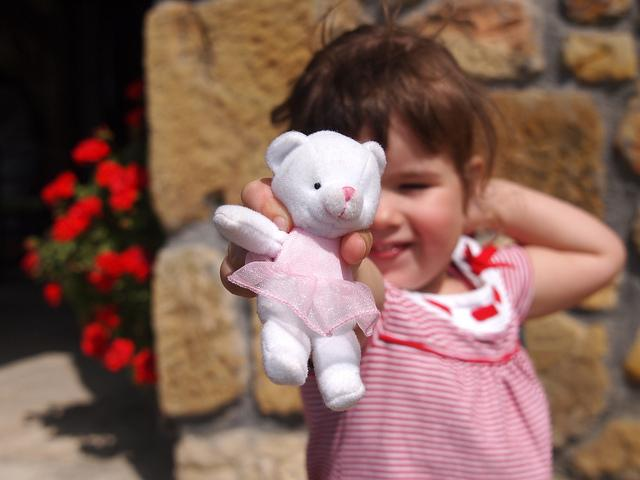What is she doing with the stuffed animal? showing 